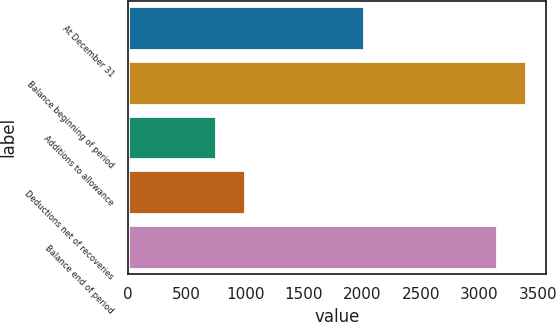Convert chart to OTSL. <chart><loc_0><loc_0><loc_500><loc_500><bar_chart><fcel>At December 31<fcel>Balance beginning of period<fcel>Additions to allowance<fcel>Deductions net of recoveries<fcel>Balance end of period<nl><fcel>2014<fcel>3395.2<fcel>748<fcel>993.2<fcel>3150<nl></chart> 